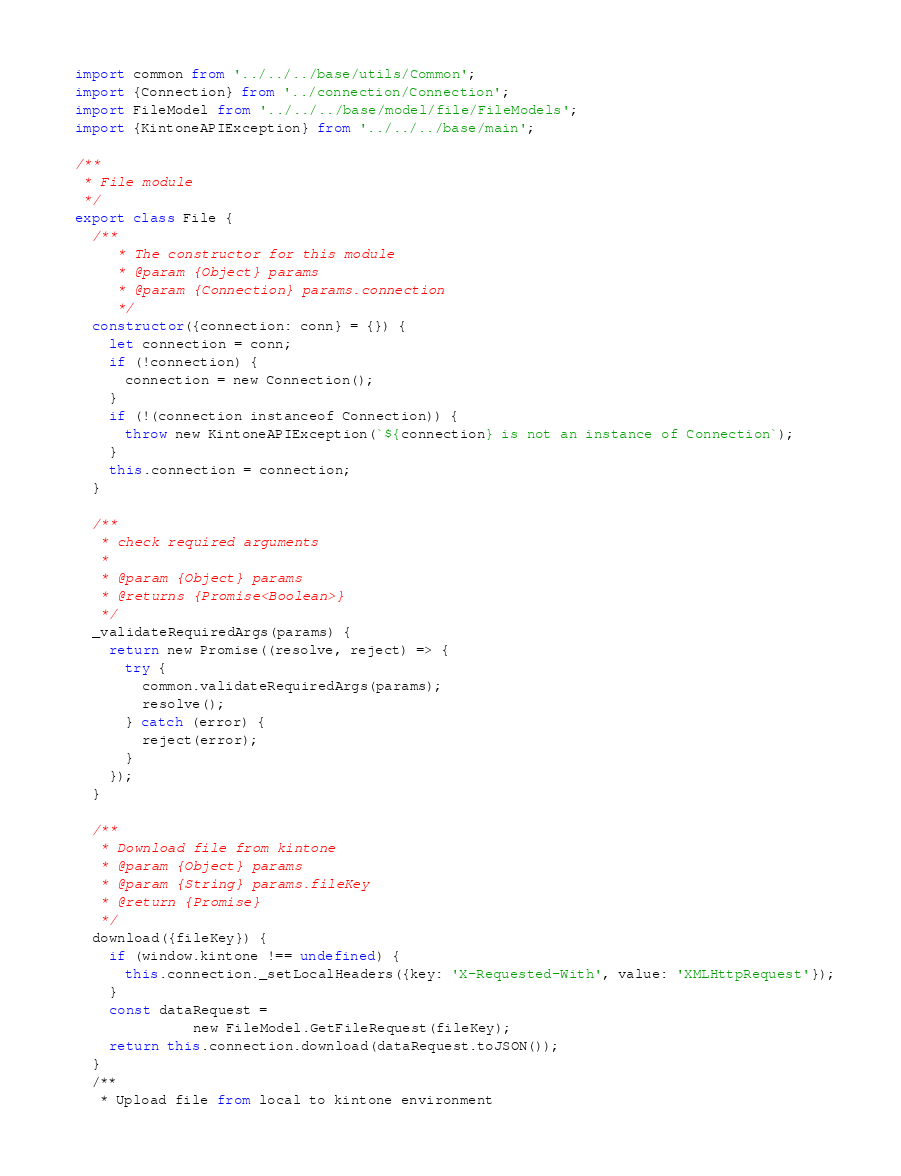<code> <loc_0><loc_0><loc_500><loc_500><_JavaScript_>import common from '../../../base/utils/Common';
import {Connection} from '../connection/Connection';
import FileModel from '../../../base/model/file/FileModels';
import {KintoneAPIException} from '../../../base/main';

/**
 * File module
 */
export class File {
  /**
     * The constructor for this module
     * @param {Object} params
     * @param {Connection} params.connection
     */
  constructor({connection: conn} = {}) {
    let connection = conn;
    if (!connection) {
      connection = new Connection();
    }
    if (!(connection instanceof Connection)) {
      throw new KintoneAPIException(`${connection} is not an instance of Connection`);
    }
    this.connection = connection;
  }

  /**
   * check required arguments
   *
   * @param {Object} params
   * @returns {Promise<Boolean>}
   */
  _validateRequiredArgs(params) {
    return new Promise((resolve, reject) => {
      try {
        common.validateRequiredArgs(params);
        resolve();
      } catch (error) {
        reject(error);
      }
    });
  }

  /**
   * Download file from kintone
   * @param {Object} params
   * @param {String} params.fileKey
   * @return {Promise}
   */
  download({fileKey}) {
    if (window.kintone !== undefined) {
      this.connection._setLocalHeaders({key: 'X-Requested-With', value: 'XMLHttpRequest'});
    }
    const dataRequest =
              new FileModel.GetFileRequest(fileKey);
    return this.connection.download(dataRequest.toJSON());
  }
  /**
   * Upload file from local to kintone environment</code> 